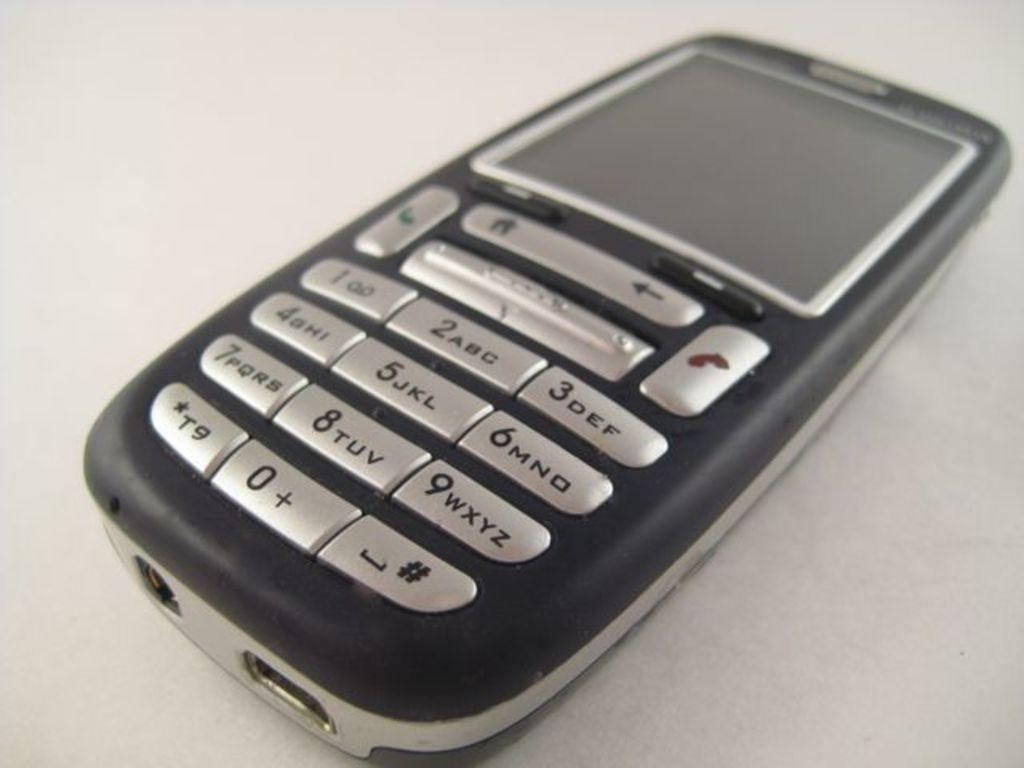<image>
Render a clear and concise summary of the photo. The top right key on the cell phone is the number 3 key 